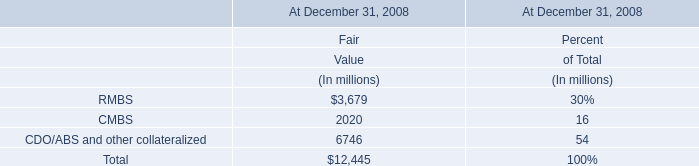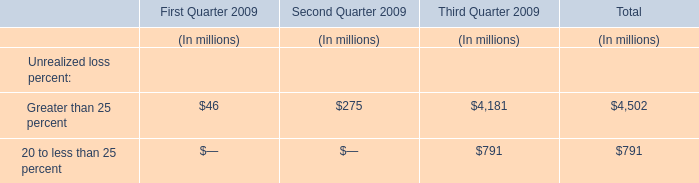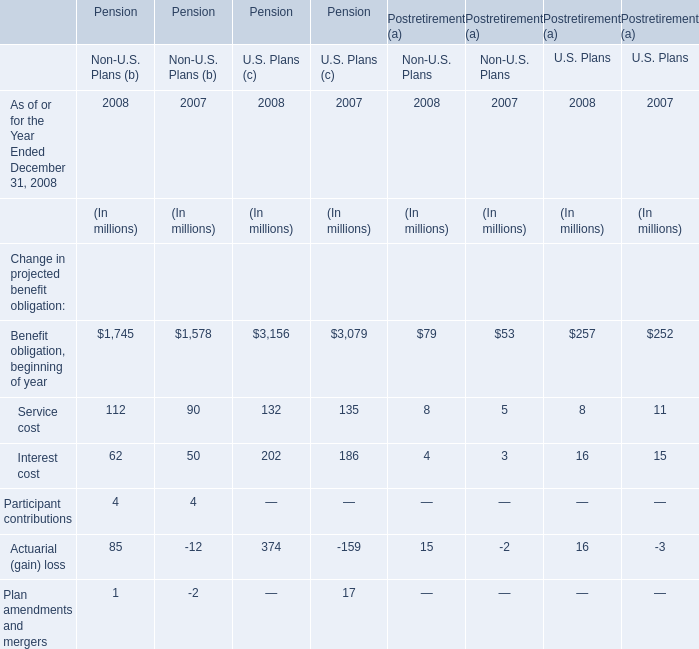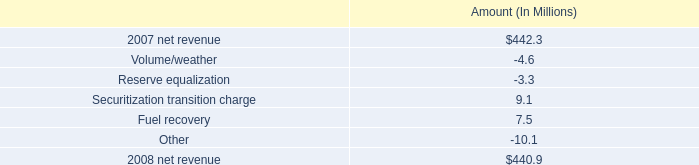what percent of the net change in revenue between 2007 and 2008 was due to fuel recovery? 
Computations: (7.5 / (440.9 - 442.3))
Answer: -5.35714. 